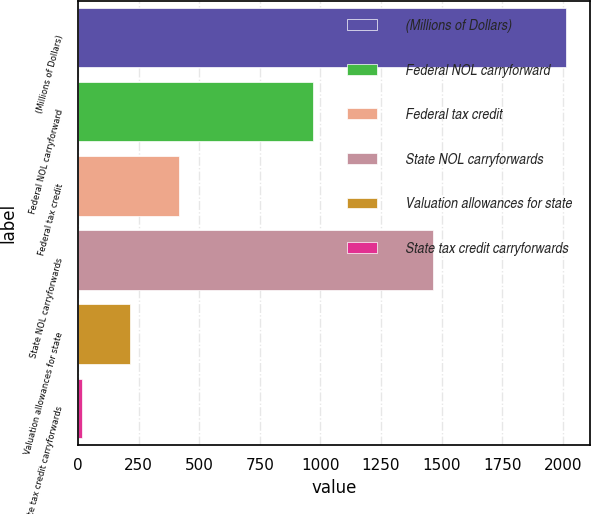Convert chart. <chart><loc_0><loc_0><loc_500><loc_500><bar_chart><fcel>(Millions of Dollars)<fcel>Federal NOL carryforward<fcel>Federal tax credit<fcel>State NOL carryforwards<fcel>Valuation allowances for state<fcel>State tax credit carryforwards<nl><fcel>2012<fcel>969<fcel>416<fcel>1465<fcel>216.5<fcel>17<nl></chart> 